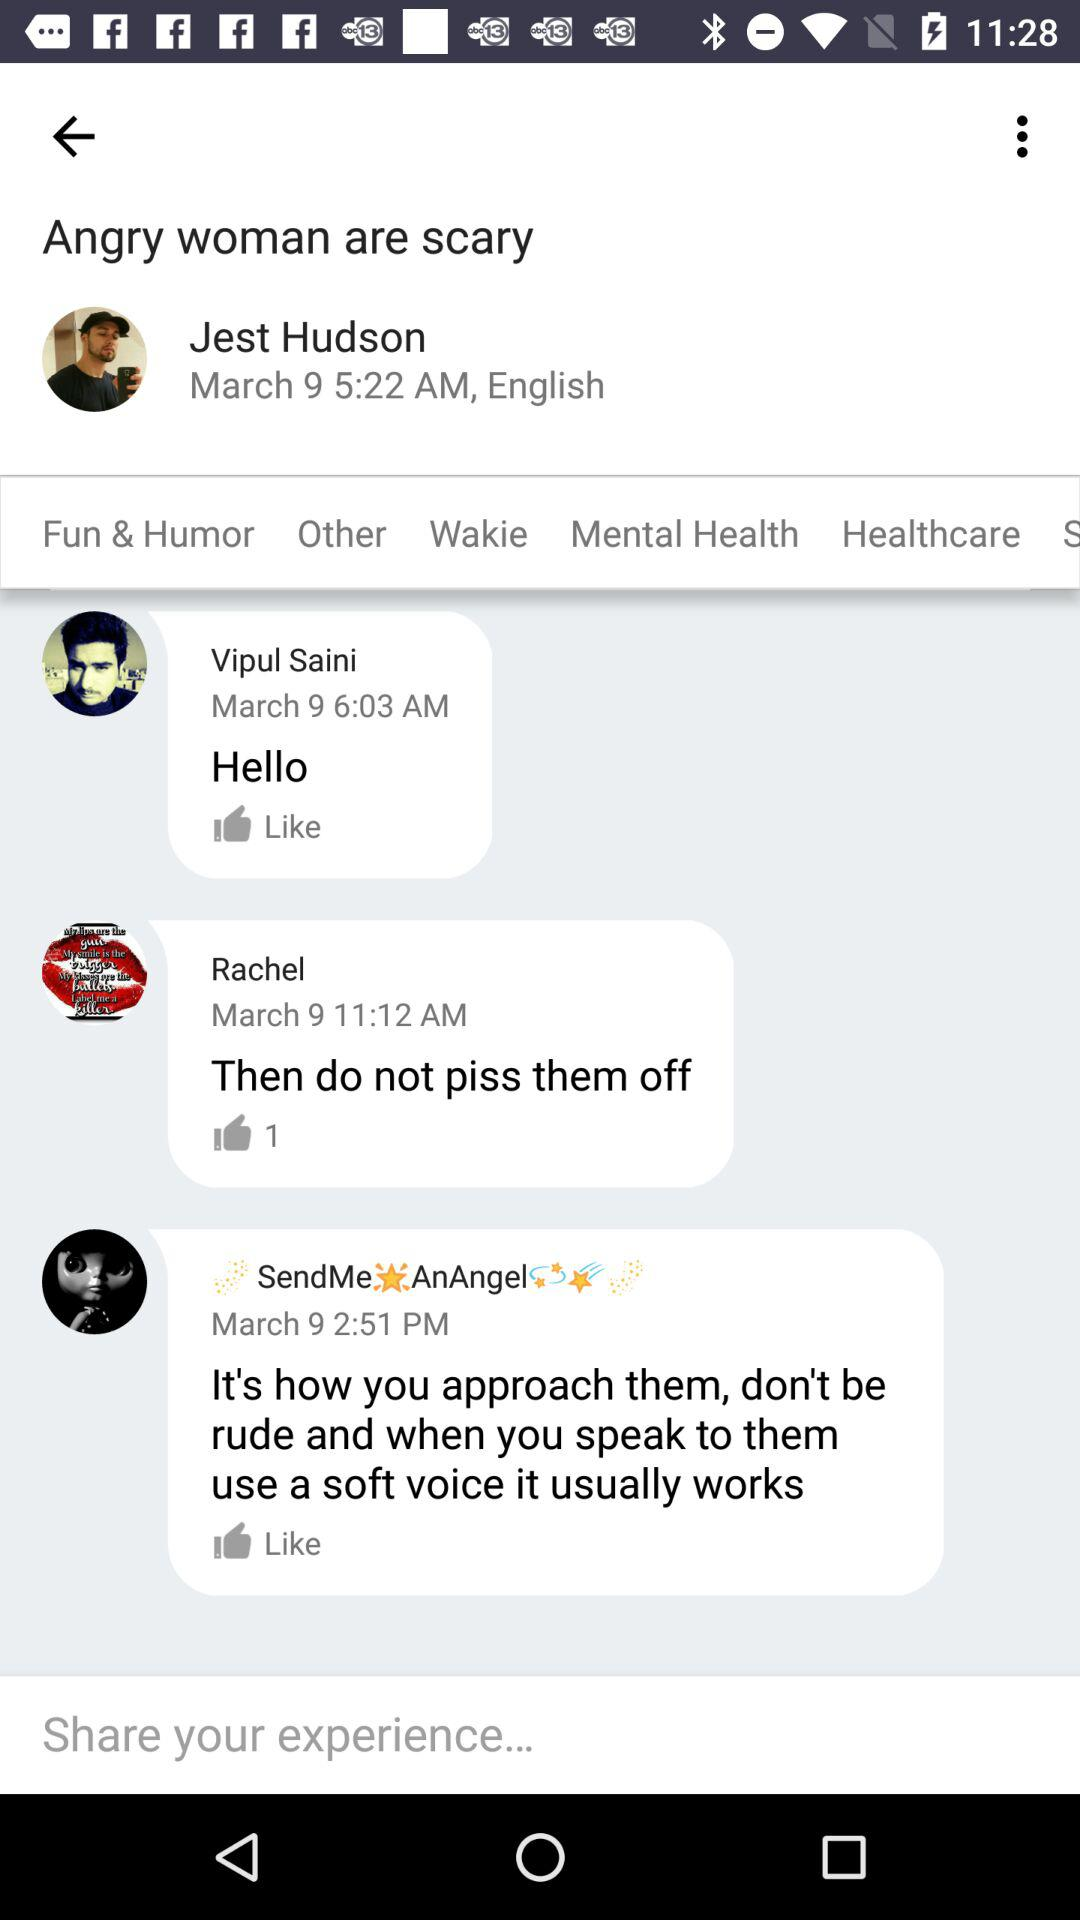When was the message "Hello" sent? The message "Hello" was sent on March 9 at 6:03 AM. 